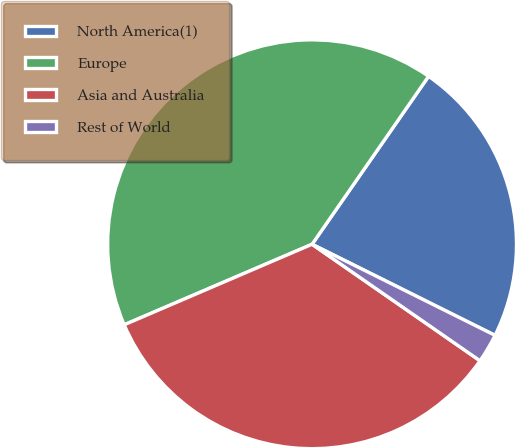Convert chart to OTSL. <chart><loc_0><loc_0><loc_500><loc_500><pie_chart><fcel>North America(1)<fcel>Europe<fcel>Asia and Australia<fcel>Rest of World<nl><fcel>22.7%<fcel>41.1%<fcel>33.9%<fcel>2.3%<nl></chart> 